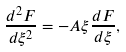<formula> <loc_0><loc_0><loc_500><loc_500>\frac { d ^ { 2 } F } { d \xi ^ { 2 } } = - A \xi \frac { d F } { d \xi } ,</formula> 